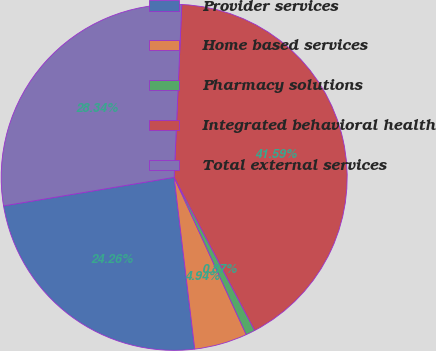Convert chart. <chart><loc_0><loc_0><loc_500><loc_500><pie_chart><fcel>Provider services<fcel>Home based services<fcel>Pharmacy solutions<fcel>Integrated behavioral health<fcel>Total external services<nl><fcel>24.26%<fcel>4.94%<fcel>0.87%<fcel>41.59%<fcel>28.34%<nl></chart> 